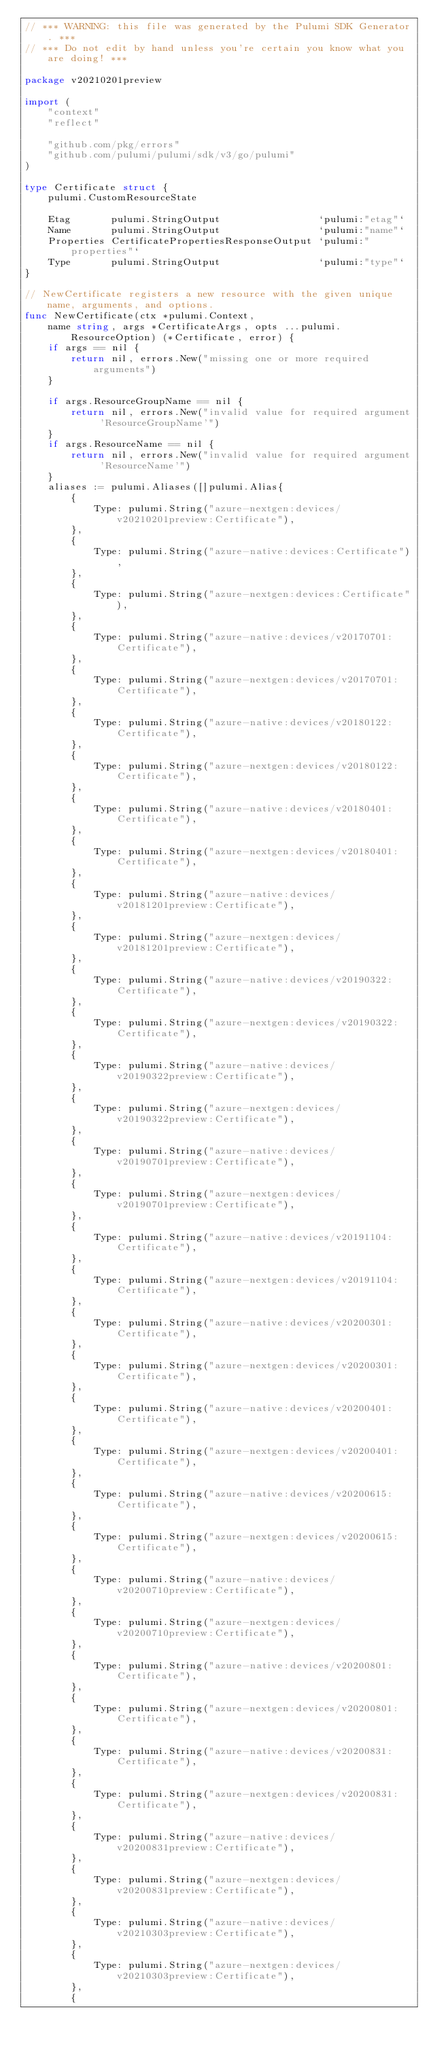Convert code to text. <code><loc_0><loc_0><loc_500><loc_500><_Go_>// *** WARNING: this file was generated by the Pulumi SDK Generator. ***
// *** Do not edit by hand unless you're certain you know what you are doing! ***

package v20210201preview

import (
	"context"
	"reflect"

	"github.com/pkg/errors"
	"github.com/pulumi/pulumi/sdk/v3/go/pulumi"
)

type Certificate struct {
	pulumi.CustomResourceState

	Etag       pulumi.StringOutput                 `pulumi:"etag"`
	Name       pulumi.StringOutput                 `pulumi:"name"`
	Properties CertificatePropertiesResponseOutput `pulumi:"properties"`
	Type       pulumi.StringOutput                 `pulumi:"type"`
}

// NewCertificate registers a new resource with the given unique name, arguments, and options.
func NewCertificate(ctx *pulumi.Context,
	name string, args *CertificateArgs, opts ...pulumi.ResourceOption) (*Certificate, error) {
	if args == nil {
		return nil, errors.New("missing one or more required arguments")
	}

	if args.ResourceGroupName == nil {
		return nil, errors.New("invalid value for required argument 'ResourceGroupName'")
	}
	if args.ResourceName == nil {
		return nil, errors.New("invalid value for required argument 'ResourceName'")
	}
	aliases := pulumi.Aliases([]pulumi.Alias{
		{
			Type: pulumi.String("azure-nextgen:devices/v20210201preview:Certificate"),
		},
		{
			Type: pulumi.String("azure-native:devices:Certificate"),
		},
		{
			Type: pulumi.String("azure-nextgen:devices:Certificate"),
		},
		{
			Type: pulumi.String("azure-native:devices/v20170701:Certificate"),
		},
		{
			Type: pulumi.String("azure-nextgen:devices/v20170701:Certificate"),
		},
		{
			Type: pulumi.String("azure-native:devices/v20180122:Certificate"),
		},
		{
			Type: pulumi.String("azure-nextgen:devices/v20180122:Certificate"),
		},
		{
			Type: pulumi.String("azure-native:devices/v20180401:Certificate"),
		},
		{
			Type: pulumi.String("azure-nextgen:devices/v20180401:Certificate"),
		},
		{
			Type: pulumi.String("azure-native:devices/v20181201preview:Certificate"),
		},
		{
			Type: pulumi.String("azure-nextgen:devices/v20181201preview:Certificate"),
		},
		{
			Type: pulumi.String("azure-native:devices/v20190322:Certificate"),
		},
		{
			Type: pulumi.String("azure-nextgen:devices/v20190322:Certificate"),
		},
		{
			Type: pulumi.String("azure-native:devices/v20190322preview:Certificate"),
		},
		{
			Type: pulumi.String("azure-nextgen:devices/v20190322preview:Certificate"),
		},
		{
			Type: pulumi.String("azure-native:devices/v20190701preview:Certificate"),
		},
		{
			Type: pulumi.String("azure-nextgen:devices/v20190701preview:Certificate"),
		},
		{
			Type: pulumi.String("azure-native:devices/v20191104:Certificate"),
		},
		{
			Type: pulumi.String("azure-nextgen:devices/v20191104:Certificate"),
		},
		{
			Type: pulumi.String("azure-native:devices/v20200301:Certificate"),
		},
		{
			Type: pulumi.String("azure-nextgen:devices/v20200301:Certificate"),
		},
		{
			Type: pulumi.String("azure-native:devices/v20200401:Certificate"),
		},
		{
			Type: pulumi.String("azure-nextgen:devices/v20200401:Certificate"),
		},
		{
			Type: pulumi.String("azure-native:devices/v20200615:Certificate"),
		},
		{
			Type: pulumi.String("azure-nextgen:devices/v20200615:Certificate"),
		},
		{
			Type: pulumi.String("azure-native:devices/v20200710preview:Certificate"),
		},
		{
			Type: pulumi.String("azure-nextgen:devices/v20200710preview:Certificate"),
		},
		{
			Type: pulumi.String("azure-native:devices/v20200801:Certificate"),
		},
		{
			Type: pulumi.String("azure-nextgen:devices/v20200801:Certificate"),
		},
		{
			Type: pulumi.String("azure-native:devices/v20200831:Certificate"),
		},
		{
			Type: pulumi.String("azure-nextgen:devices/v20200831:Certificate"),
		},
		{
			Type: pulumi.String("azure-native:devices/v20200831preview:Certificate"),
		},
		{
			Type: pulumi.String("azure-nextgen:devices/v20200831preview:Certificate"),
		},
		{
			Type: pulumi.String("azure-native:devices/v20210303preview:Certificate"),
		},
		{
			Type: pulumi.String("azure-nextgen:devices/v20210303preview:Certificate"),
		},
		{</code> 